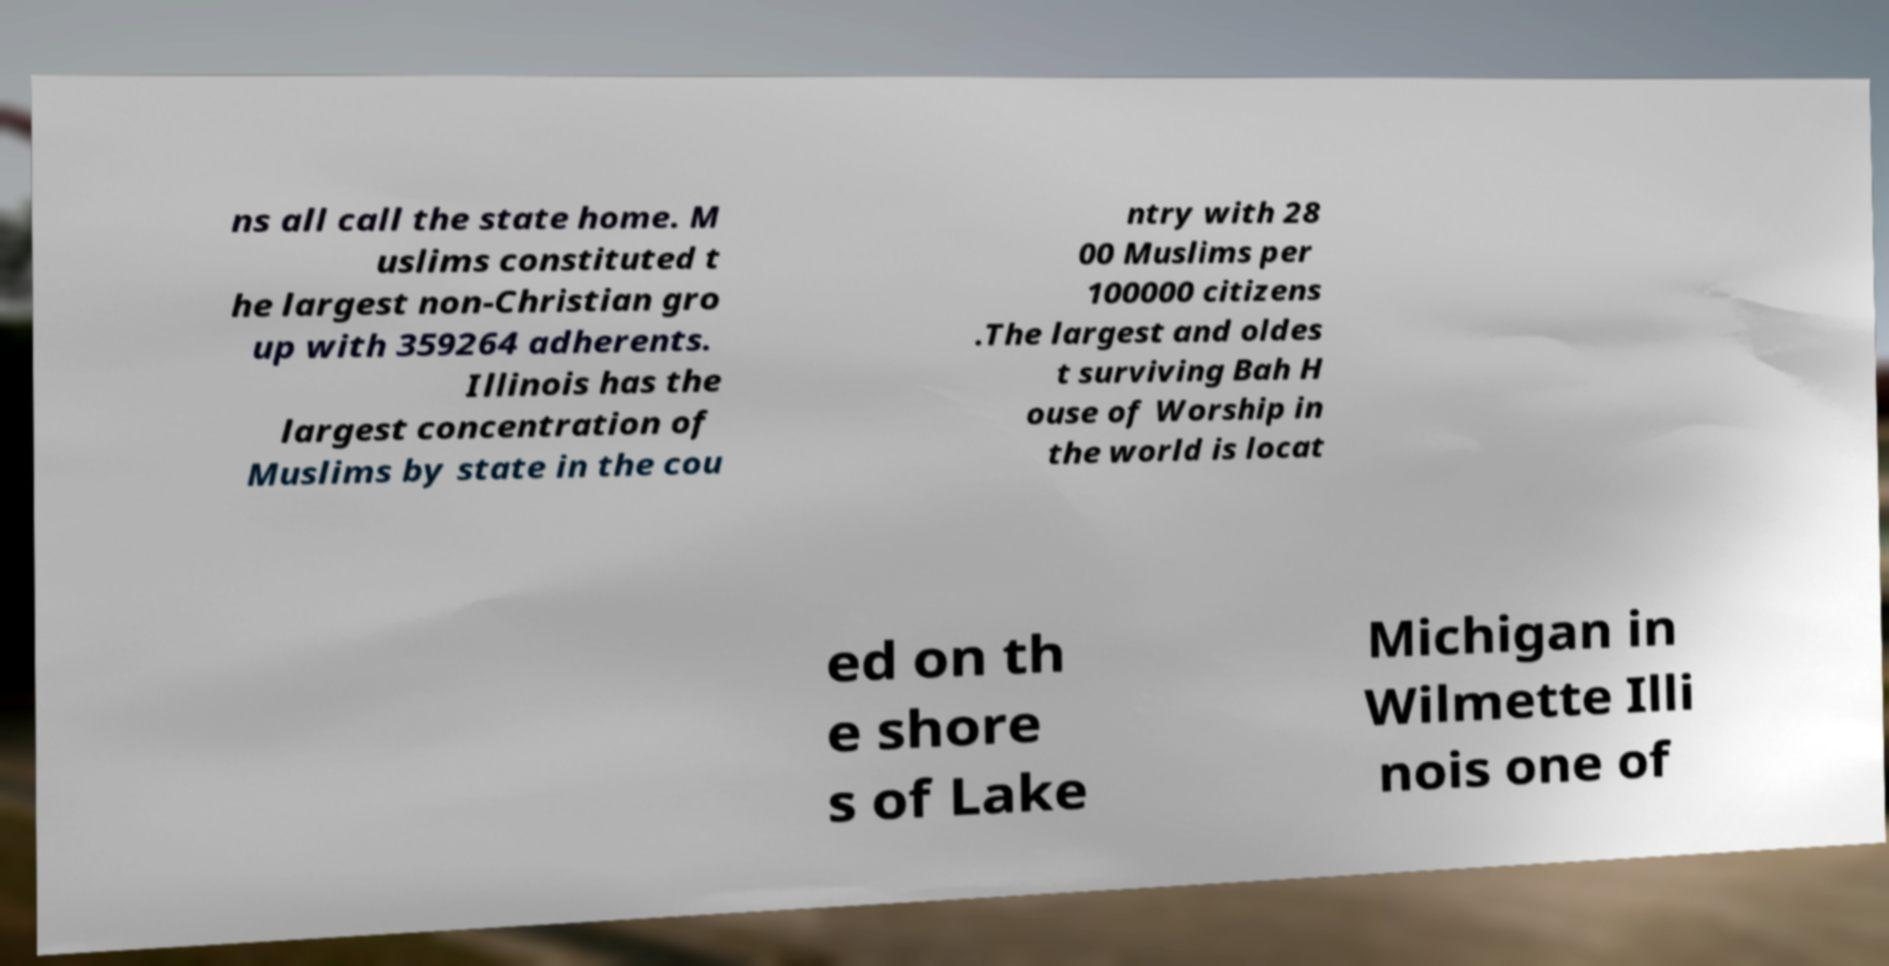What messages or text are displayed in this image? I need them in a readable, typed format. ns all call the state home. M uslims constituted t he largest non-Christian gro up with 359264 adherents. Illinois has the largest concentration of Muslims by state in the cou ntry with 28 00 Muslims per 100000 citizens .The largest and oldes t surviving Bah H ouse of Worship in the world is locat ed on th e shore s of Lake Michigan in Wilmette Illi nois one of 